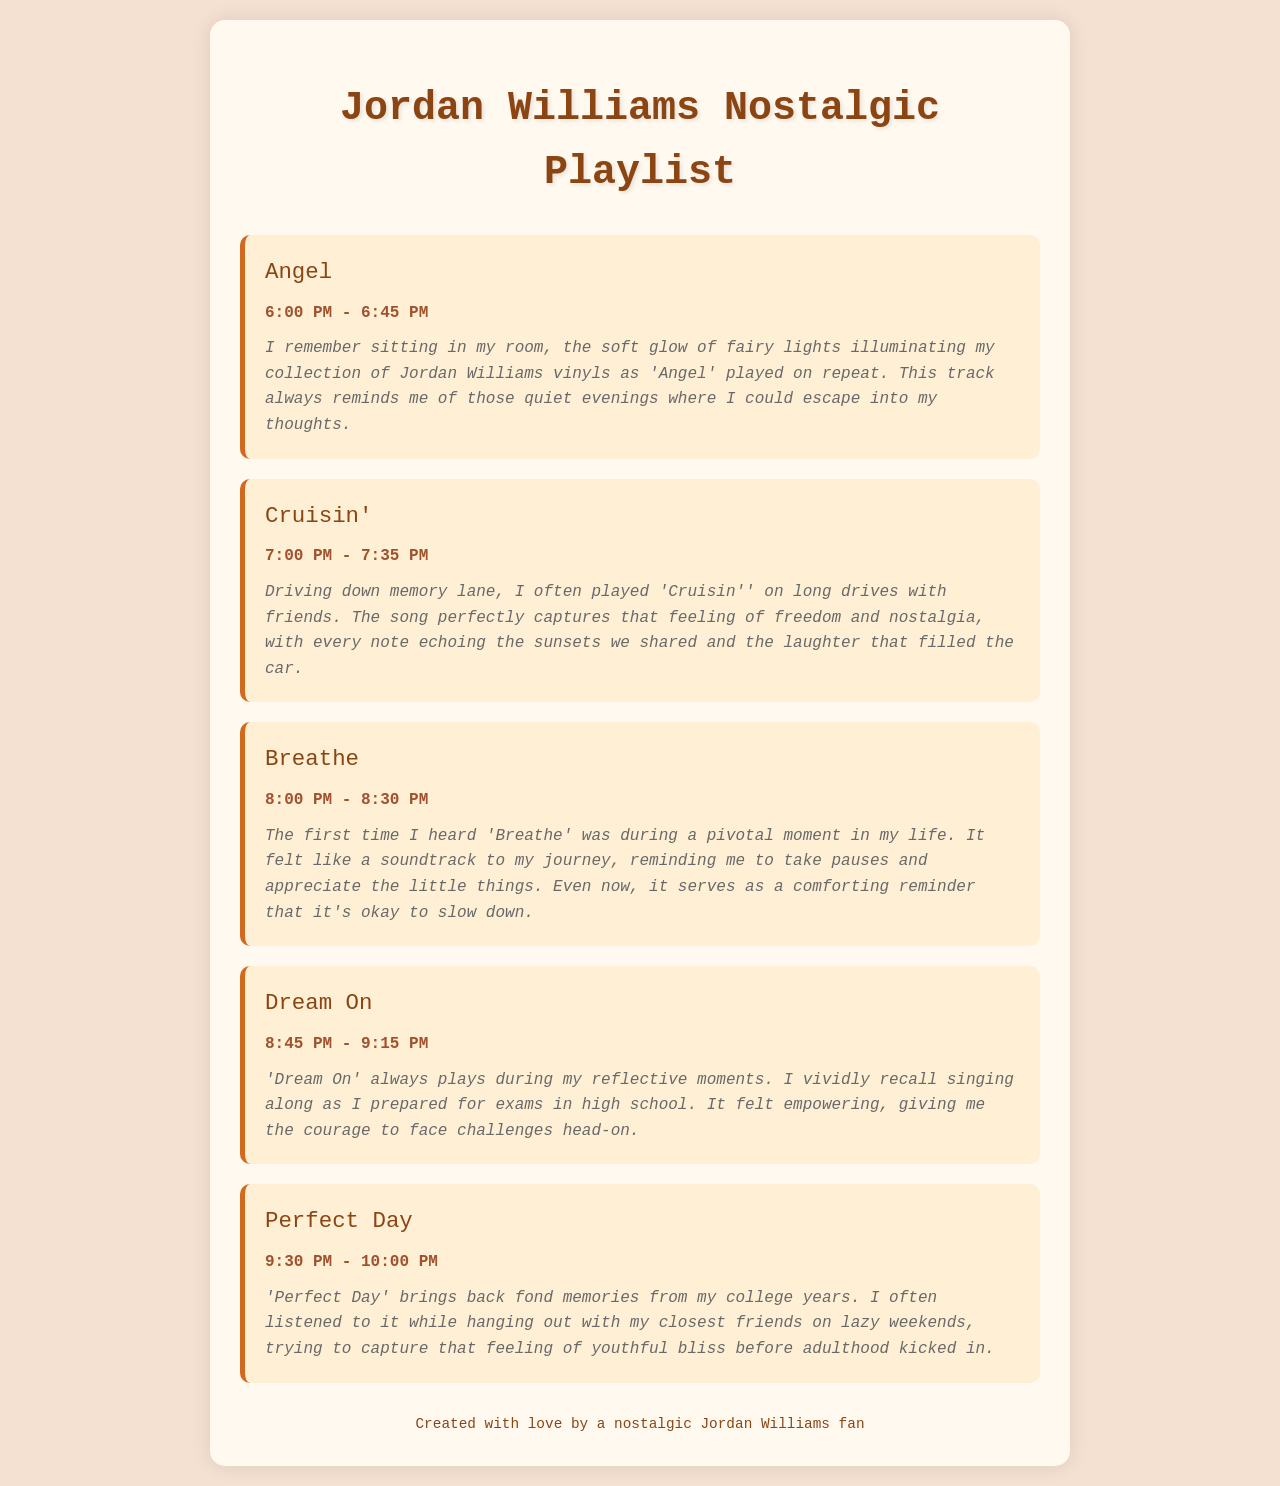What is the first track in the playlist? The first track listed is the one that appears at the top of the playlist items, which is 'Angel'.
Answer: Angel What time does 'Cruisin'' play? The start and end times for 'Cruisin'' are specified in the document, which are 7:00 PM - 7:35 PM.
Answer: 7:00 PM - 7:35 PM How long is the song 'Breathe'? The listening time for 'Breathe' indicates its duration, which is from 8:00 PM to 8:30 PM, making it 30 minutes long.
Answer: 30 minutes What is the personal anecdote associated with 'Dream On'? The anecdote for 'Dream On' describes a reflective moment connected to preparing for exams in high school.
Answer: Singing along as I prepared for exams in high school Which track reminds the listener of college years? The track that evokes memories from college years is 'Perfect Day', as mentioned in the related anecdote.
Answer: Perfect Day What color is the background of the document? The color is described in the stylesheet section of the code as a soft, light color, specifically #f4e1d2.
Answer: #f4e1d2 How many tracks are listed in the playlist? Counting all the tracks in the playlist, there are five distinct songs mentioned.
Answer: Five At what time does the playlist conclude? The final track's end time determines when the playlist concludes, which is at 10:00 PM.
Answer: 10:00 PM 